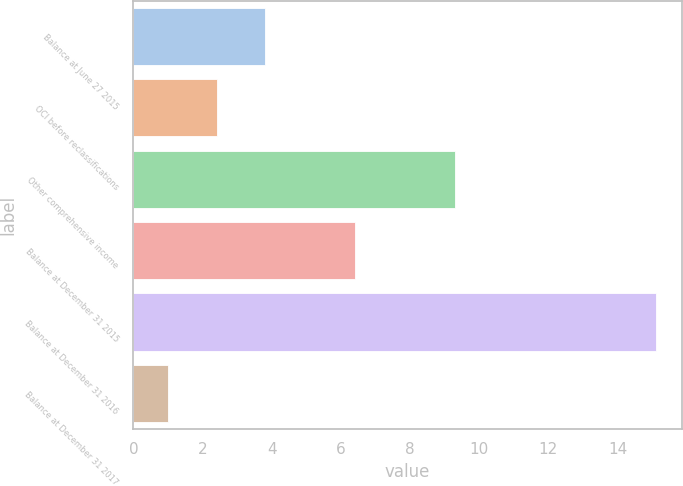Convert chart to OTSL. <chart><loc_0><loc_0><loc_500><loc_500><bar_chart><fcel>Balance at June 27 2015<fcel>OCI before reclassifications<fcel>Other comprehensive income<fcel>Balance at December 31 2015<fcel>Balance at December 31 2016<fcel>Balance at December 31 2017<nl><fcel>3.82<fcel>2.41<fcel>9.3<fcel>6.4<fcel>15.1<fcel>1<nl></chart> 